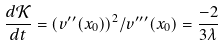Convert formula to latex. <formula><loc_0><loc_0><loc_500><loc_500>\frac { d \mathcal { K } } { d t } = ( v ^ { \prime \prime } ( x _ { 0 } ) ) ^ { 2 } / v ^ { \prime \prime \prime } ( x _ { 0 } ) = \frac { - 2 } { 3 \lambda }</formula> 